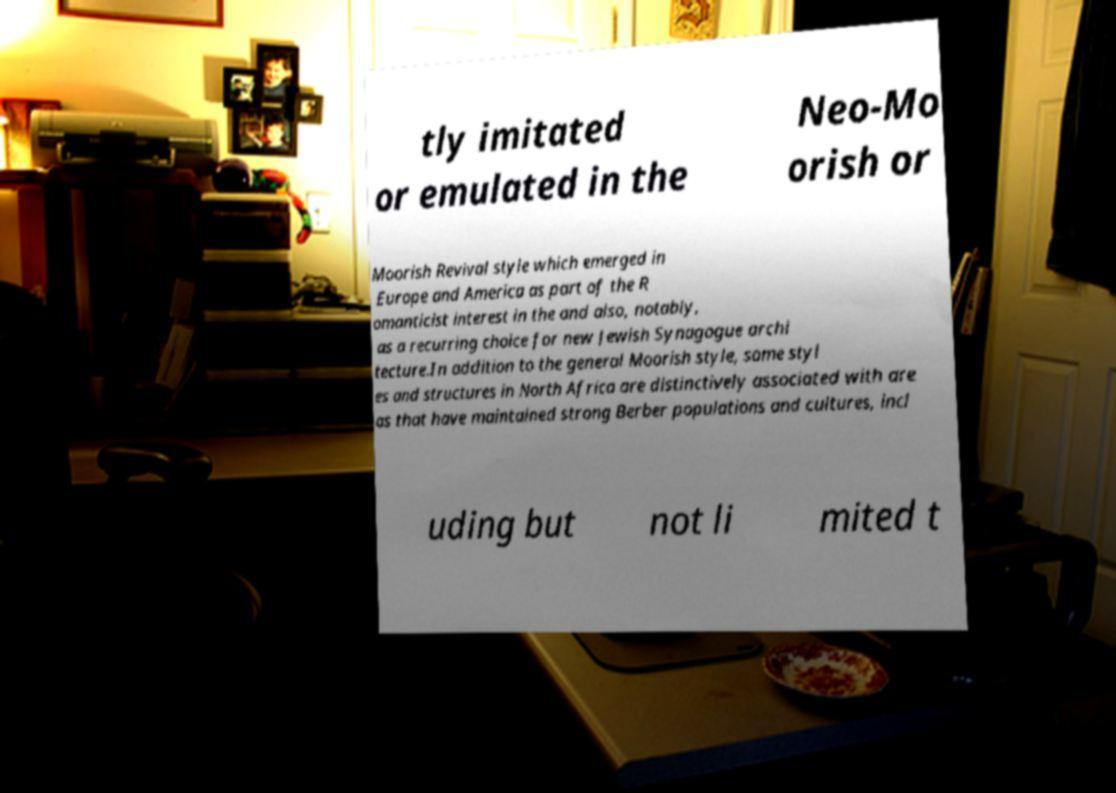Please read and relay the text visible in this image. What does it say? tly imitated or emulated in the Neo-Mo orish or Moorish Revival style which emerged in Europe and America as part of the R omanticist interest in the and also, notably, as a recurring choice for new Jewish Synagogue archi tecture.In addition to the general Moorish style, some styl es and structures in North Africa are distinctively associated with are as that have maintained strong Berber populations and cultures, incl uding but not li mited t 